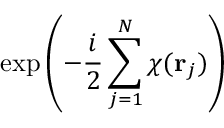Convert formula to latex. <formula><loc_0><loc_0><loc_500><loc_500>\exp \left ( - { \frac { i } { 2 } } \sum _ { j = 1 } ^ { N } \chi ( { r } _ { j } ) \right )</formula> 